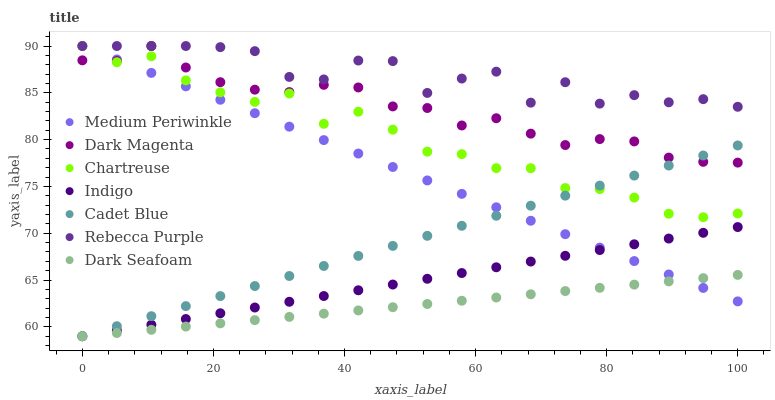Does Dark Seafoam have the minimum area under the curve?
Answer yes or no. Yes. Does Rebecca Purple have the maximum area under the curve?
Answer yes or no. Yes. Does Indigo have the minimum area under the curve?
Answer yes or no. No. Does Indigo have the maximum area under the curve?
Answer yes or no. No. Is Dark Seafoam the smoothest?
Answer yes or no. Yes. Is Rebecca Purple the roughest?
Answer yes or no. Yes. Is Indigo the smoothest?
Answer yes or no. No. Is Indigo the roughest?
Answer yes or no. No. Does Cadet Blue have the lowest value?
Answer yes or no. Yes. Does Dark Magenta have the lowest value?
Answer yes or no. No. Does Rebecca Purple have the highest value?
Answer yes or no. Yes. Does Indigo have the highest value?
Answer yes or no. No. Is Indigo less than Chartreuse?
Answer yes or no. Yes. Is Rebecca Purple greater than Dark Seafoam?
Answer yes or no. Yes. Does Dark Magenta intersect Medium Periwinkle?
Answer yes or no. Yes. Is Dark Magenta less than Medium Periwinkle?
Answer yes or no. No. Is Dark Magenta greater than Medium Periwinkle?
Answer yes or no. No. Does Indigo intersect Chartreuse?
Answer yes or no. No. 